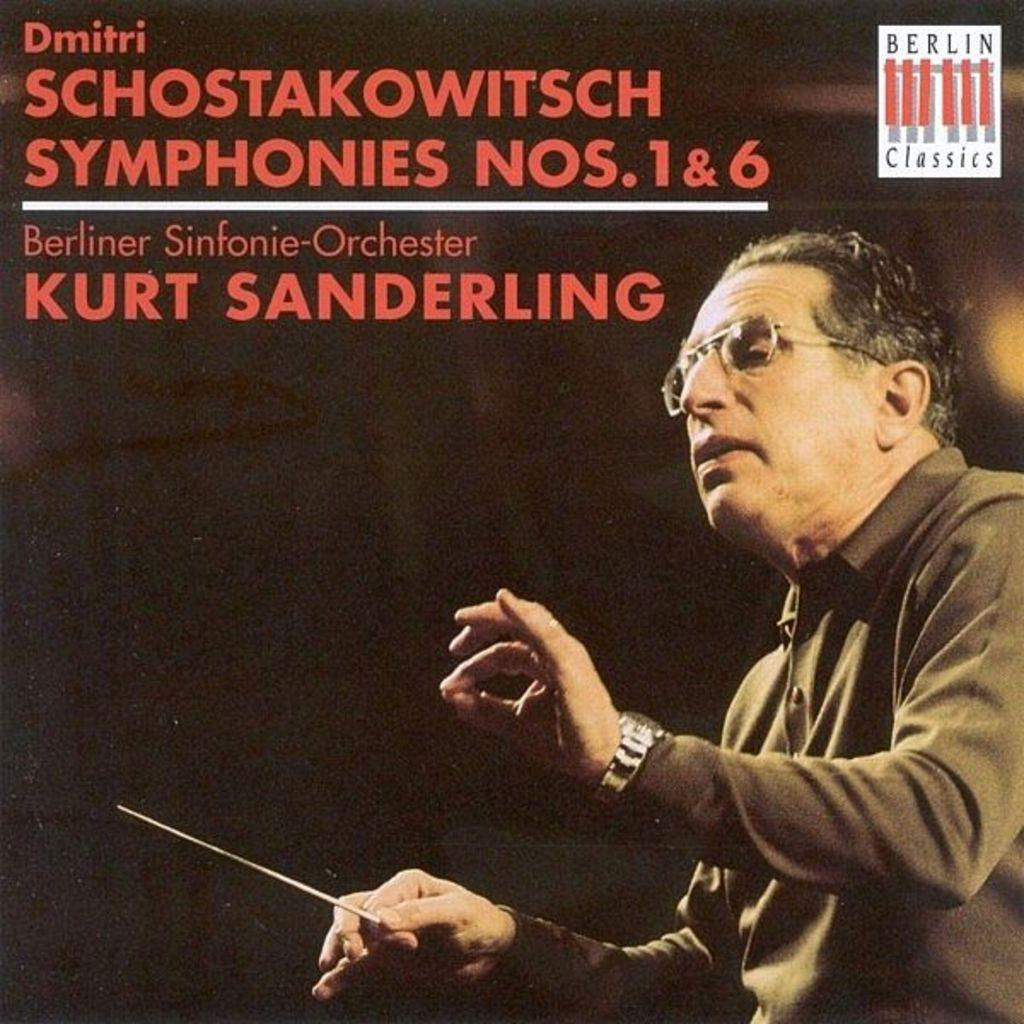What is depicted on the poster in the image? There is a poster of a person in the image. What is the person holding in the poster? The person is holding a stick in the poster. What accessory is the person wearing in the poster? The person is wearing spectacles in the poster. Is there any text or writing on the poster? Yes, there is text or writing on the poster. What type of tomatoes is the person teaching in the image? There is no person teaching in the image, nor are there any tomatoes present. 